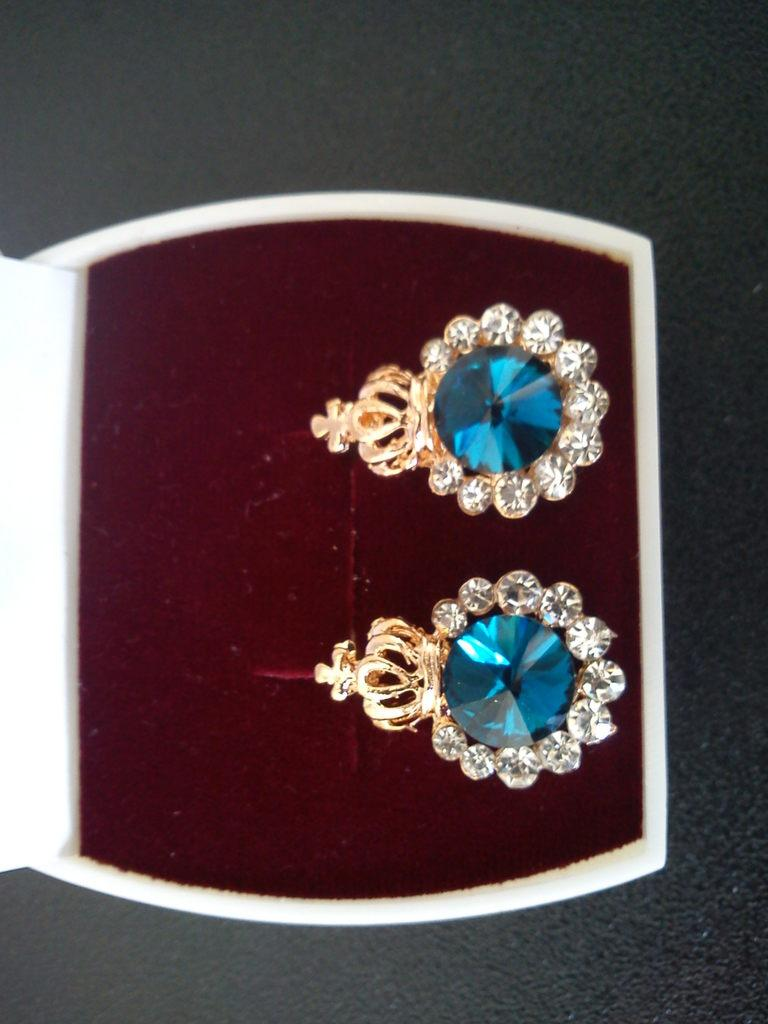What type of accessory is present in the image? There are earrings in the image. Where are the earrings stored in the image? The earrings are placed in a jewelry box. What is the primary piece of furniture visible in the image? There is a table at the bottom of the image. What type of bean is visible in the image? There are no beans present in the image. What is the aftermath of the battle in the image? There is no battle or any indication of one in the image. 